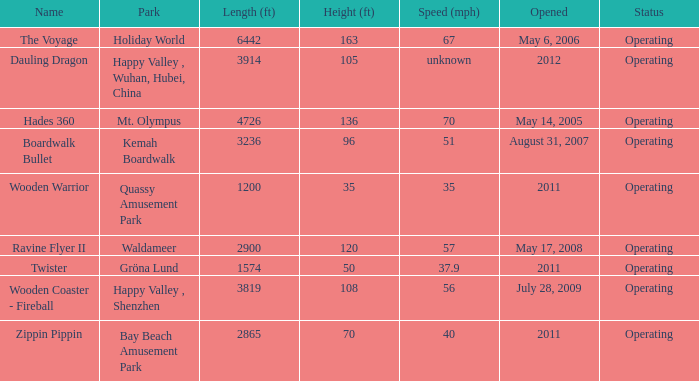What is the length of the coaster with the unknown speed 3914.0. 